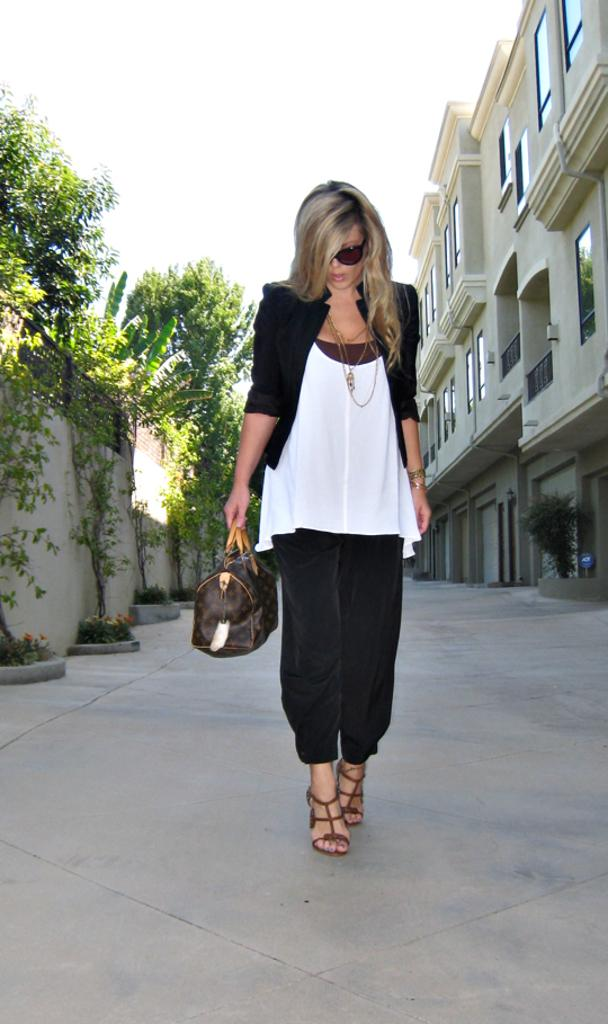What is the main subject of the image? There is a woman standing in the image. What is the woman holding in her hand? The woman is holding a bag in her hand. What can be seen in the background of the image? There is a building and trees in the background of the image. What is visible at the top of the image? The sky is visible at the top of the image. What type of friction can be seen between the woman's shoes and the ground in the image? There is no information about the friction between the woman's shoes and the ground in the image. Can you tell me how many feathers are on the woman's hat in the image? There is no hat or feathers present in the image. 